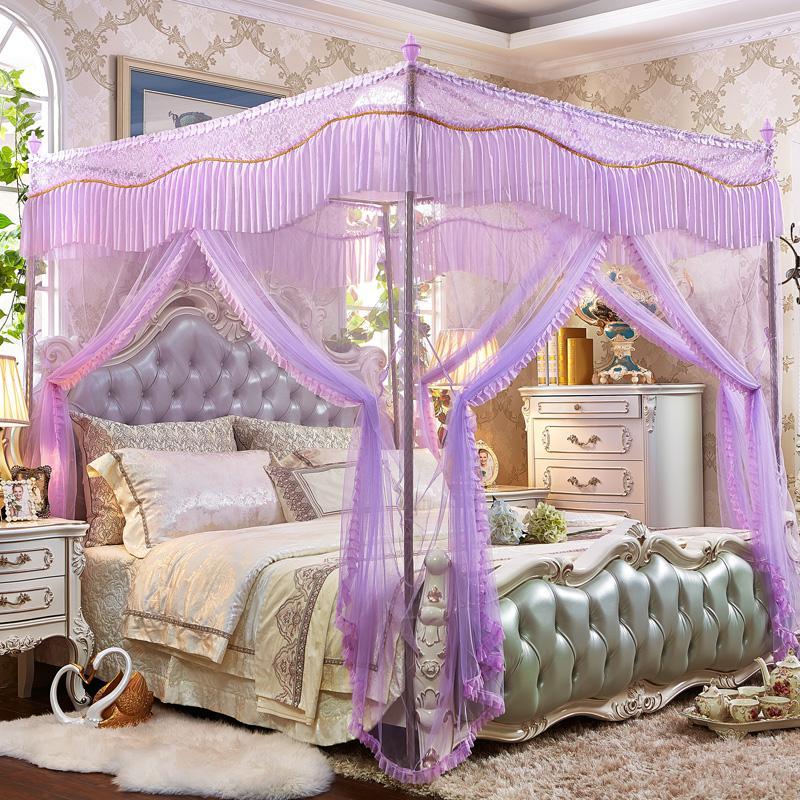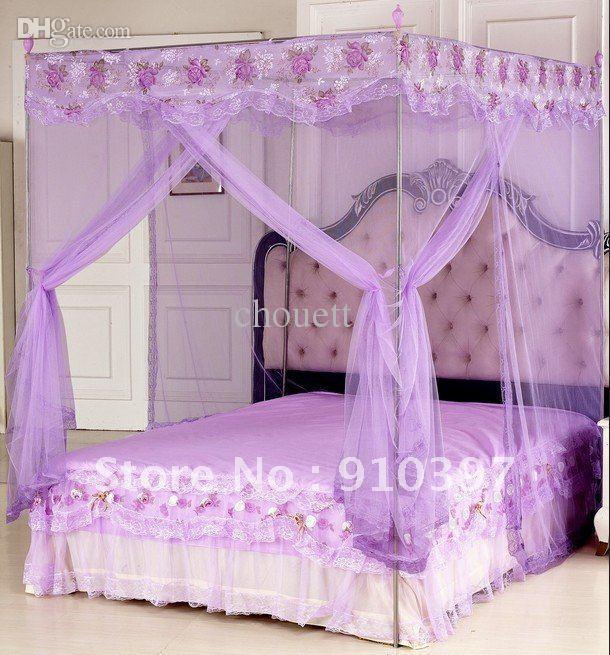The first image is the image on the left, the second image is the image on the right. For the images displayed, is the sentence "All of the bed nets are purple." factually correct? Answer yes or no. Yes. The first image is the image on the left, the second image is the image on the right. Evaluate the accuracy of this statement regarding the images: "There are two purple bed canopies with headboards that are visible through them.". Is it true? Answer yes or no. Yes. 